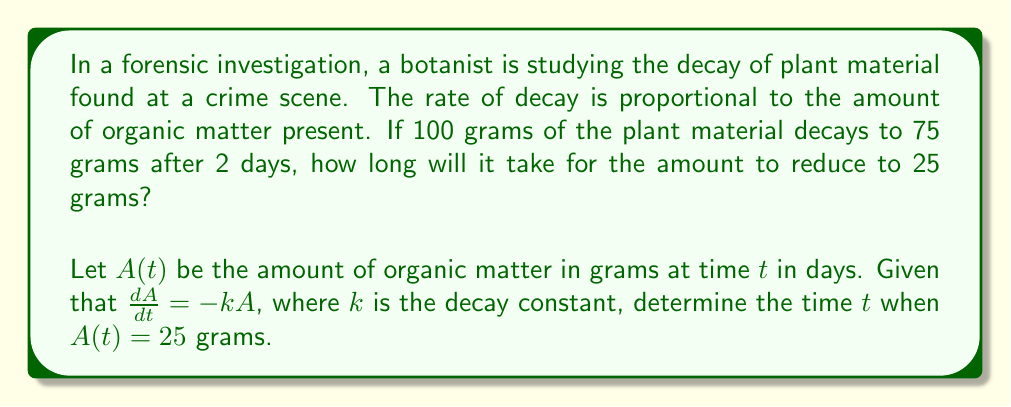Could you help me with this problem? To solve this problem, we'll follow these steps:

1) The differential equation describing the decay is:

   $$\frac{dA}{dt} = -kA$$

2) The solution to this equation is:

   $$A(t) = A_0e^{-kt}$$

   where $A_0$ is the initial amount.

3) We're given that $A(0) = 100$ and $A(2) = 75$. Let's use these to find $k$:

   $$75 = 100e^{-2k}$$

4) Solving for $k$:

   $$\ln(\frac{75}{100}) = -2k$$
   $$k = -\frac{1}{2}\ln(\frac{3}{4}) \approx 0.1438$$

5) Now that we have $k$, we can use the equation to find $t$ when $A(t) = 25$:

   $$25 = 100e^{-0.1438t}$$

6) Solving for $t$:

   $$\ln(\frac{25}{100}) = -0.1438t$$
   $$t = -\frac{1}{0.1438}\ln(\frac{1}{4}) \approx 9.6259$$

Therefore, it will take approximately 9.63 days for the amount to reduce to 25 grams.
Answer: $t \approx 9.63$ days 